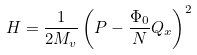<formula> <loc_0><loc_0><loc_500><loc_500>H = \frac { 1 } { 2 M _ { v } } \left ( P - \frac { \Phi _ { 0 } } { N } Q _ { x } \right ) ^ { 2 }</formula> 